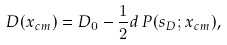Convert formula to latex. <formula><loc_0><loc_0><loc_500><loc_500>D ( x _ { c m } ) = D _ { 0 } - \frac { 1 } { 2 } d \, P ( s _ { D } ; x _ { c m } ) ,</formula> 